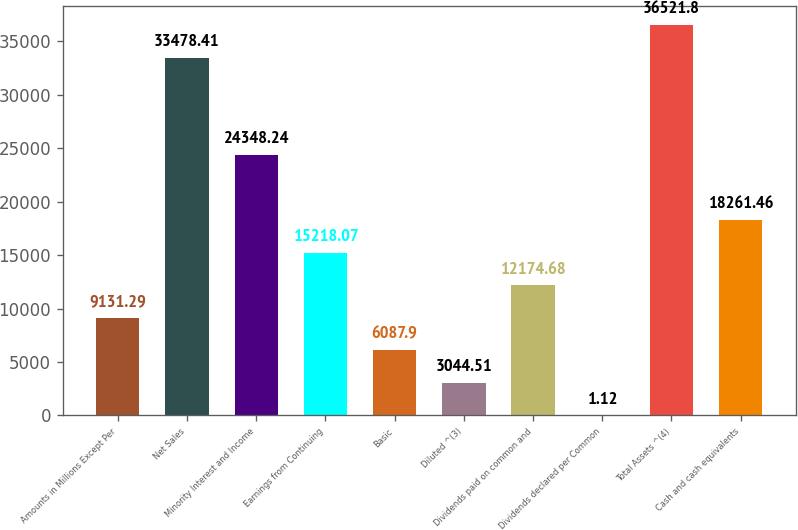<chart> <loc_0><loc_0><loc_500><loc_500><bar_chart><fcel>Amounts in Millions Except Per<fcel>Net Sales<fcel>Minority Interest and Income<fcel>Earnings from Continuing<fcel>Basic<fcel>Diluted ^(3)<fcel>Dividends paid on common and<fcel>Dividends declared per Common<fcel>Total Assets ^(4)<fcel>Cash and cash equivalents<nl><fcel>9131.29<fcel>33478.4<fcel>24348.2<fcel>15218.1<fcel>6087.9<fcel>3044.51<fcel>12174.7<fcel>1.12<fcel>36521.8<fcel>18261.5<nl></chart> 